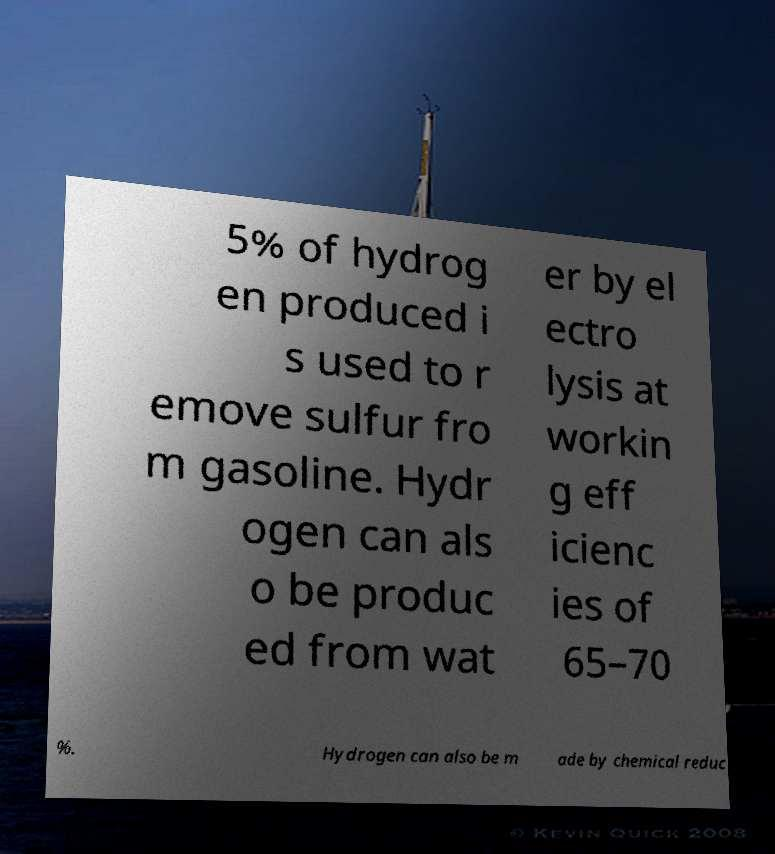Can you read and provide the text displayed in the image?This photo seems to have some interesting text. Can you extract and type it out for me? 5% of hydrog en produced i s used to r emove sulfur fro m gasoline. Hydr ogen can als o be produc ed from wat er by el ectro lysis at workin g eff icienc ies of 65–70 %. Hydrogen can also be m ade by chemical reduc 